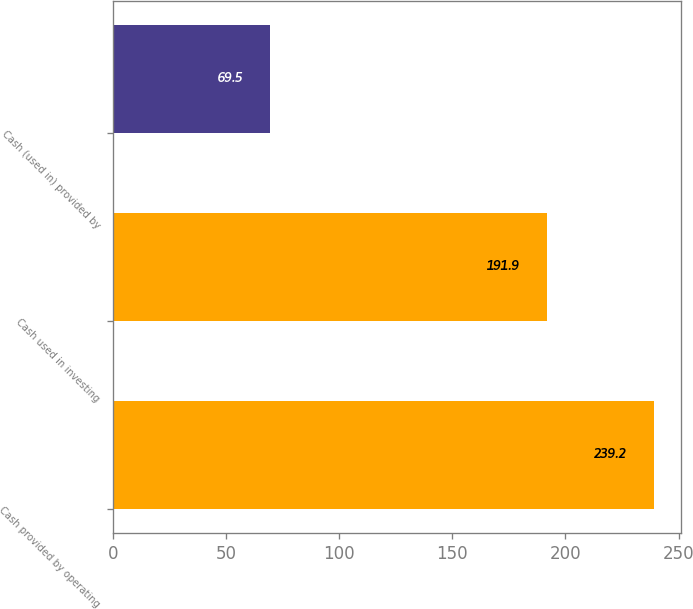Convert chart to OTSL. <chart><loc_0><loc_0><loc_500><loc_500><bar_chart><fcel>Cash provided by operating<fcel>Cash used in investing<fcel>Cash (used in) provided by<nl><fcel>239.2<fcel>191.9<fcel>69.5<nl></chart> 